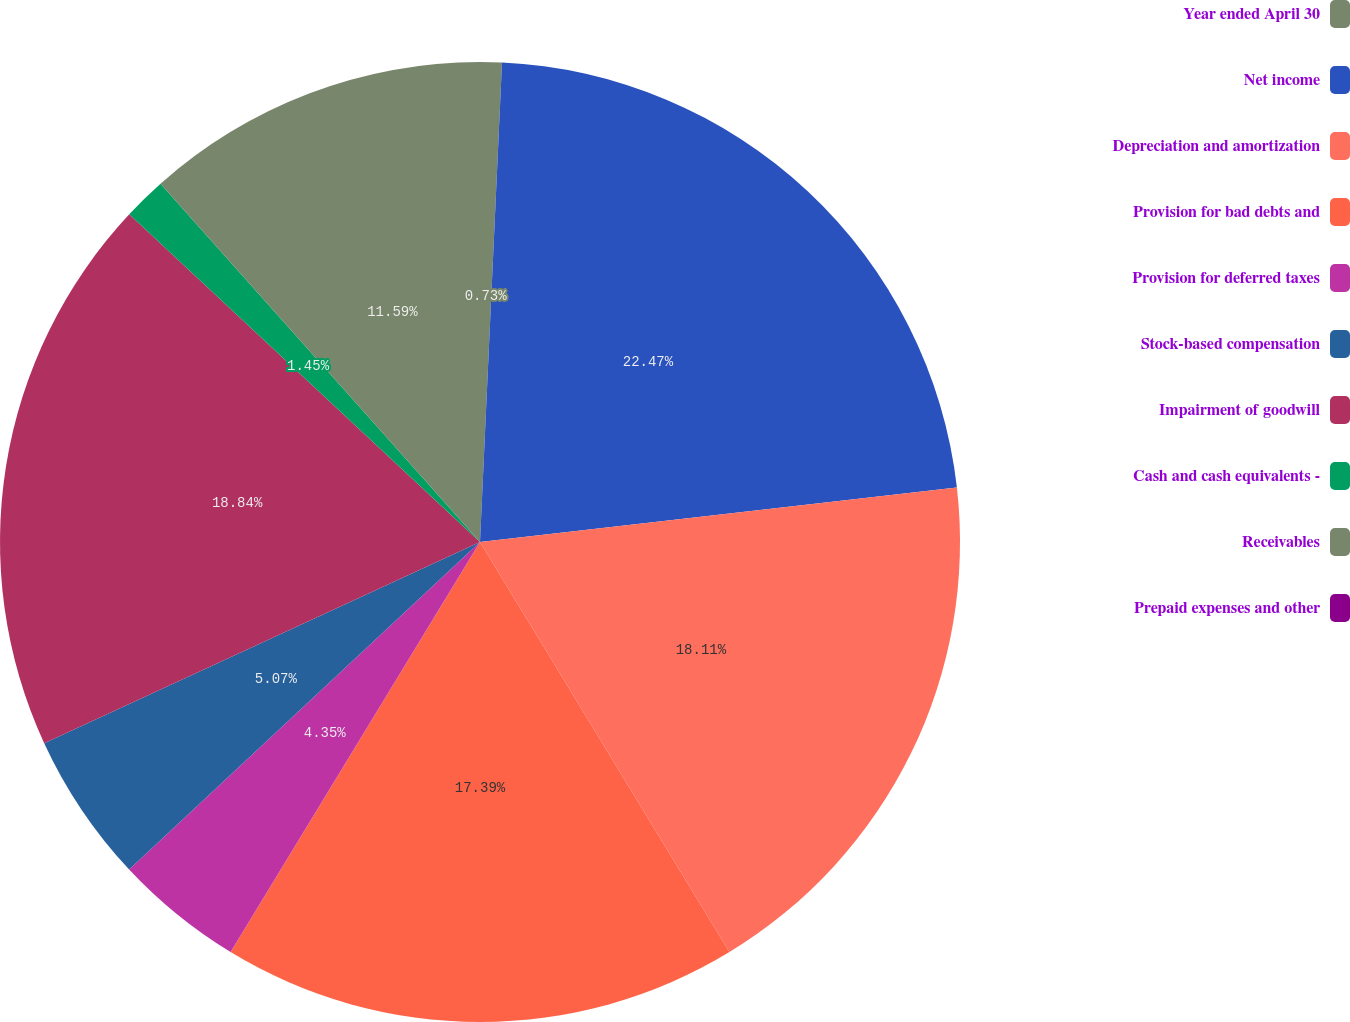<chart> <loc_0><loc_0><loc_500><loc_500><pie_chart><fcel>Year ended April 30<fcel>Net income<fcel>Depreciation and amortization<fcel>Provision for bad debts and<fcel>Provision for deferred taxes<fcel>Stock-based compensation<fcel>Impairment of goodwill<fcel>Cash and cash equivalents -<fcel>Receivables<fcel>Prepaid expenses and other<nl><fcel>0.73%<fcel>22.46%<fcel>18.11%<fcel>17.39%<fcel>4.35%<fcel>5.07%<fcel>18.84%<fcel>1.45%<fcel>11.59%<fcel>0.0%<nl></chart> 